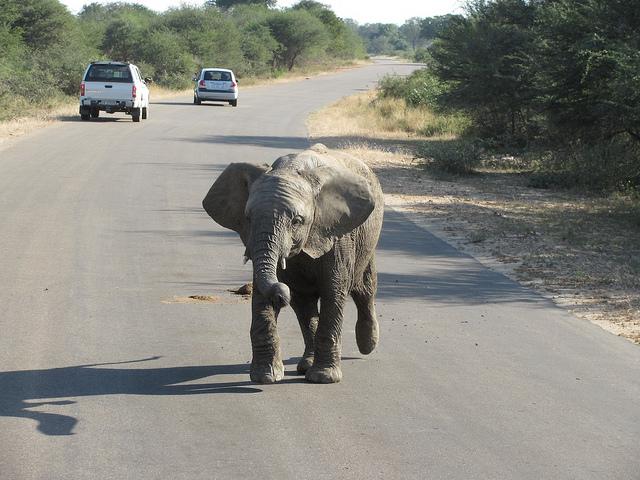Is the elephant going for a walk?
Give a very brief answer. Yes. How many cars are there?
Answer briefly. 2. Would ivory poachers be very tempted to hunt this elephant?
Answer briefly. No. 